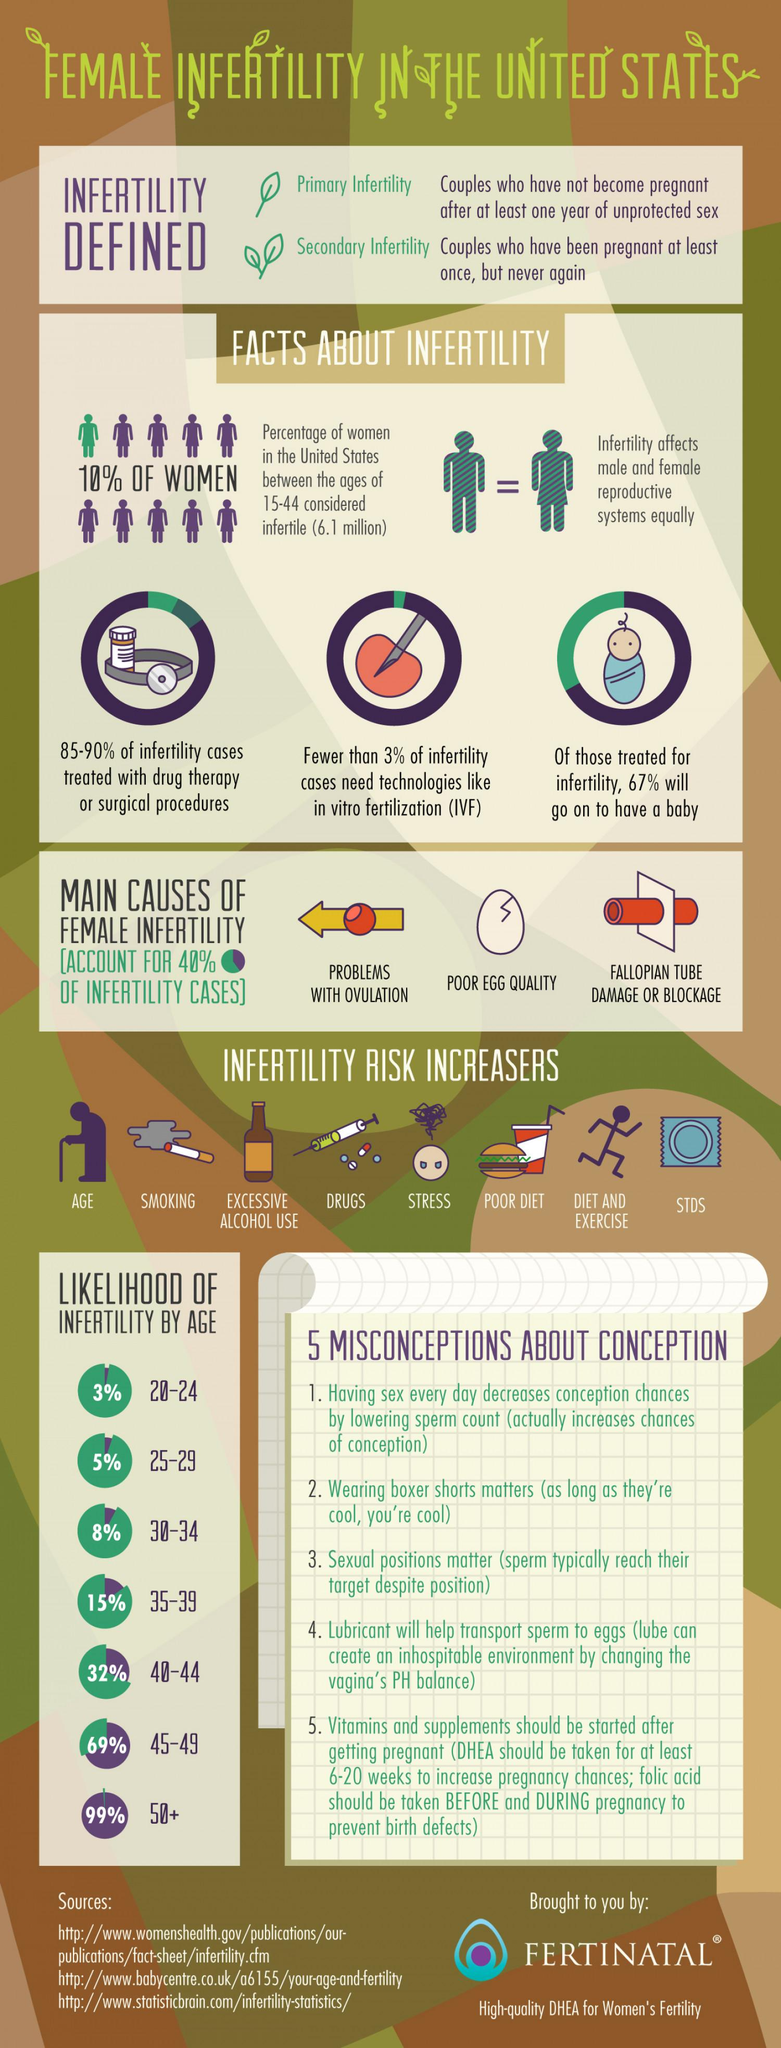Outline some significant characteristics in this image. There are two main stages of infertility in females: primary infertility, which refers to the inability to conceive after one year of trying, and secondary infertility, which refers to the inability to conceive after previously having had a child. The fertile female population in the United States in the age group of 15-44 is approximately 6.1 million. In the United States, the age group that is considered to be the least fertile among females is 50 years old and above. In the United States, the age group that is considered the most fertile in females is 20-24 years old. In the United States, less than 3% of infertility cases require the use of technologies like in vitro fertilization (IVF). 